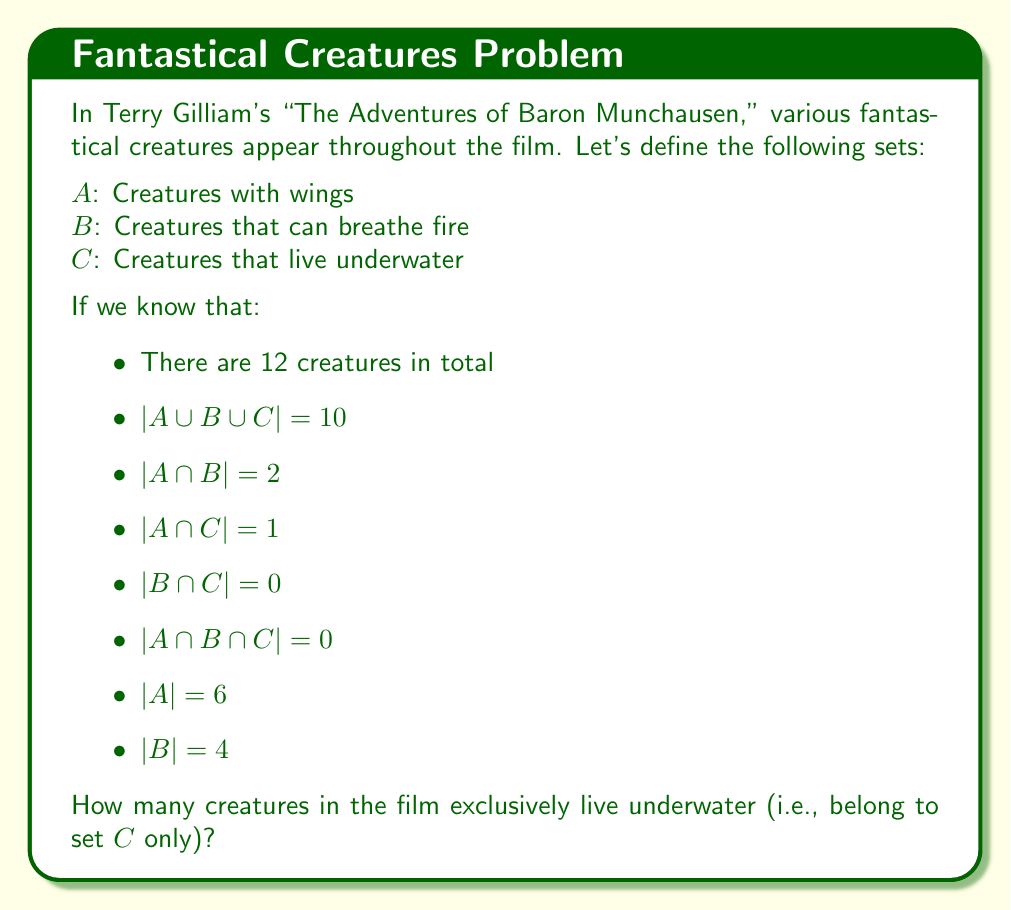Solve this math problem. Let's approach this step-by-step using set theory:

1) First, we'll use the principle of inclusion-exclusion for three sets:

   $|A \cup B \cup C| = |A| + |B| + |C| - |A \cap B| - |A \cap C| - |B \cap C| + |A \cap B \cap C|$

2) We're given that $|A \cup B \cup C| = 10$, so let's substitute the known values:

   $10 = 6 + 4 + |C| - 2 - 1 - 0 + 0$

3) Simplify:

   $10 = 7 + |C|$

4) Solve for $|C|$:

   $|C| = 10 - 7 = 3$

5) Now we know the total number of underwater creatures, but we need to find how many are exclusively underwater. We know that one creature is in both $A$ and $C$, so:

   $|C \text{ only}| = |C| - |A \cap C| = 3 - 1 = 2$

6) We can verify this result by checking the total number of creatures:
   - 6 winged creatures (set $A$)
   - 4 fire-breathing creatures (set $B$)
   - 2 exclusively underwater creatures (set $C$ only)

   $6 + 4 + 2 = 12$, which matches our given total.

This analysis not only solves the problem but also illustrates how Gilliam's imaginative creatures can be categorized and analyzed using mathematical set theory, demonstrating the intersection of film studies and mathematics.
Answer: 2 creatures exclusively live underwater. 